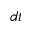<formula> <loc_0><loc_0><loc_500><loc_500>d t</formula> 